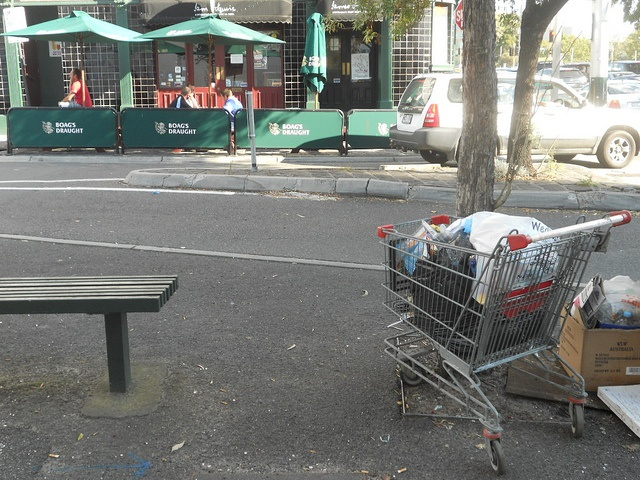Describe the objects in this image and their specific colors. I can see car in gray, white, darkgray, and lightgray tones, bench in gray, black, darkgray, and lightgray tones, umbrella in gray, lightblue, aquamarine, and teal tones, umbrella in gray, ivory, turquoise, and black tones, and umbrella in gray, teal, aquamarine, ivory, and black tones in this image. 